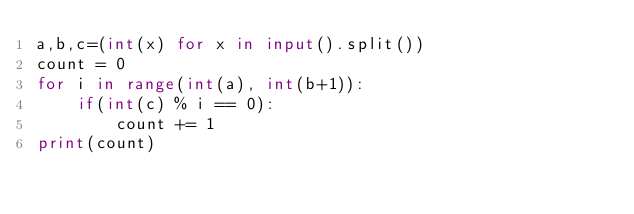Convert code to text. <code><loc_0><loc_0><loc_500><loc_500><_Python_>a,b,c=(int(x) for x in input().split())
count = 0
for i in range(int(a), int(b+1)):
    if(int(c) % i == 0):
        count += 1
print(count)
</code> 